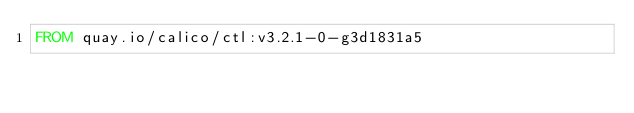Convert code to text. <code><loc_0><loc_0><loc_500><loc_500><_Dockerfile_>FROM quay.io/calico/ctl:v3.2.1-0-g3d1831a5
</code> 